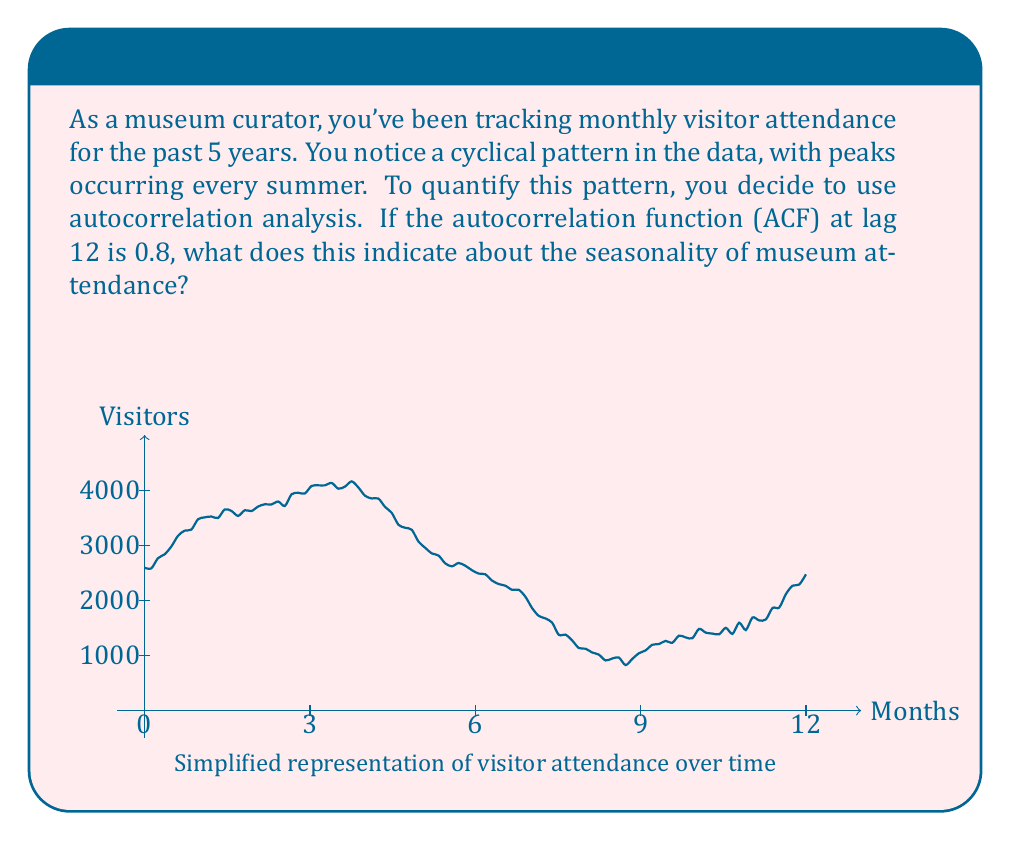Teach me how to tackle this problem. To understand the significance of the autocorrelation function (ACF) at lag 12 being 0.8, let's break down the concept and its implications:

1) Autocorrelation measures the correlation between a time series and a lagged version of itself. It helps identify repeating patterns or seasonality in the data.

2) The lag represents the time shift. A lag of 12 in monthly data corresponds to a full year.

3) ACF values range from -1 to 1:
   - 1 indicates perfect positive correlation
   - 0 indicates no correlation
   - -1 indicates perfect negative correlation

4) An ACF of 0.8 at lag 12 suggests a strong positive correlation between the current month's attendance and the attendance 12 months ago.

5) In the context of museum attendance:
   - This high positive correlation at a 12-month lag strongly indicates an annual seasonal pattern.
   - It means that the attendance levels tend to be similar at the same time each year.

6) The mathematical interpretation:

   Let $Y_t$ be the attendance at time $t$, then:

   $$ACF(12) = \frac{Cov(Y_t, Y_{t-12})}{\sqrt{Var(Y_t)Var(Y_{t-12})}} = 0.8$$

   This indicates that 80% of the variance in attendance can be explained by the previous year's attendance at the same month.

7) In the museum context, this likely reflects:
   - Higher attendance during summer months (tourist season)
   - Lower attendance during winter months
   - Consistent patterns for special exhibits or events held annually

Therefore, an ACF of 0.8 at lag 12 strongly supports the observation of a cyclical pattern with peaks occurring every summer, quantifying the seasonality in museum attendance.
Answer: Strong annual seasonality in museum attendance 